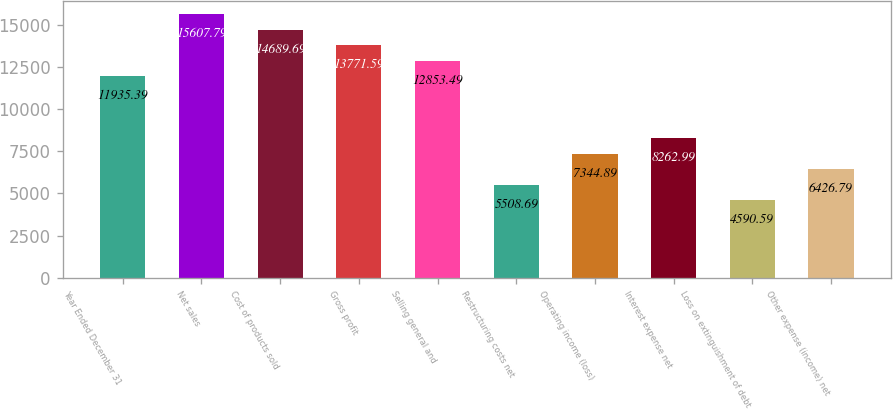<chart> <loc_0><loc_0><loc_500><loc_500><bar_chart><fcel>Year Ended December 31<fcel>Net sales<fcel>Cost of products sold<fcel>Gross profit<fcel>Selling general and<fcel>Restructuring costs net<fcel>Operating income (loss)<fcel>Interest expense net<fcel>Loss on extinguishment of debt<fcel>Other expense (income) net<nl><fcel>11935.4<fcel>15607.8<fcel>14689.7<fcel>13771.6<fcel>12853.5<fcel>5508.69<fcel>7344.89<fcel>8262.99<fcel>4590.59<fcel>6426.79<nl></chart> 